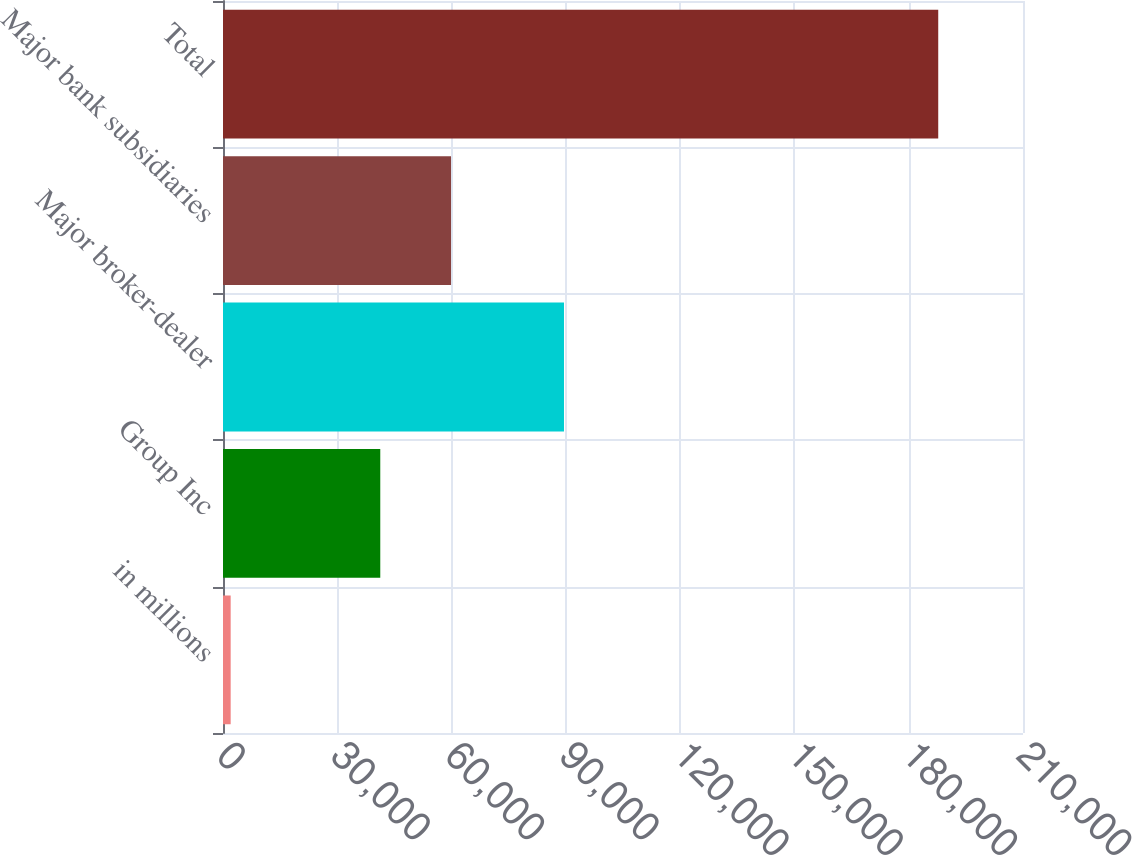Convert chart. <chart><loc_0><loc_0><loc_500><loc_500><bar_chart><fcel>in millions<fcel>Group Inc<fcel>Major broker-dealer<fcel>Major bank subsidiaries<fcel>Total<nl><fcel>2015<fcel>41284<fcel>89510<fcel>59857.3<fcel>187748<nl></chart> 